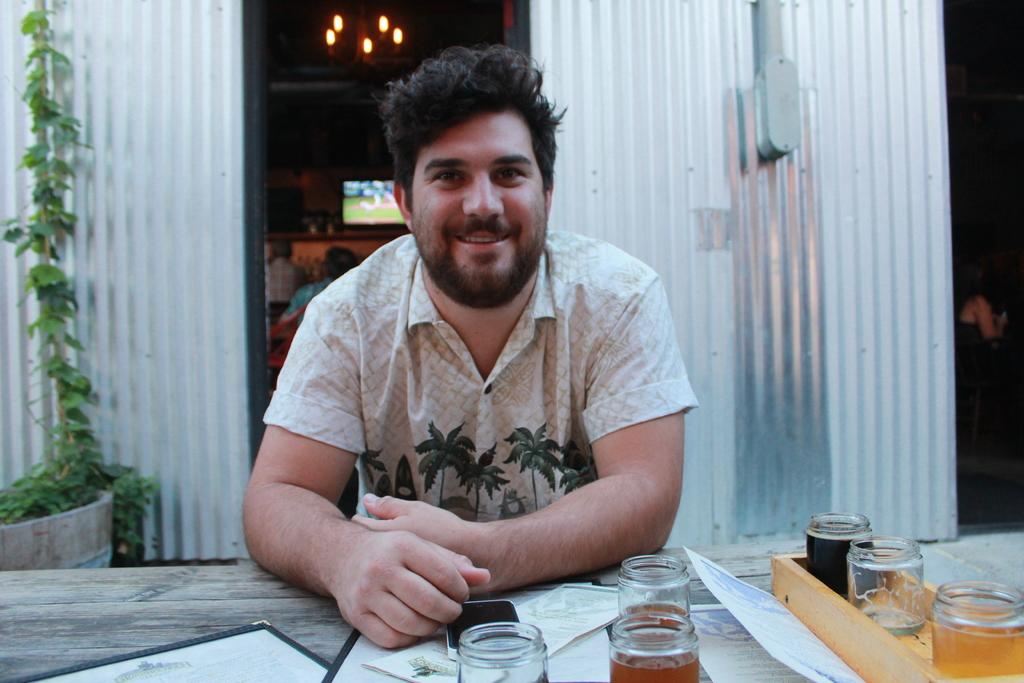What is the man in the image doing? The man is sitting on a chair in the image. Where is the man located in relation to the table? The man is in front of a table in the image. What can be seen on the table in the image? There are objects on the table in the image. What type of books can be seen in the library in the image? There is no library present in the image; it features a man sitting on a chair in front of a table. 